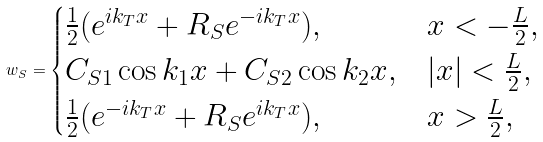<formula> <loc_0><loc_0><loc_500><loc_500>w _ { S } = \begin{cases} \frac { 1 } { 2 } ( e ^ { i k _ { T } x } + R _ { S } e ^ { - i k _ { T } x } ) , & x < - \frac { L } { 2 } , \\ C _ { S 1 } \cos k _ { 1 } x + C _ { S 2 } \cos k _ { 2 } x , & | x | < \frac { L } { 2 } , \\ \frac { 1 } { 2 } ( e ^ { - i k _ { T } x } + R _ { S } e ^ { i k _ { T } x } ) , & x > \frac { L } { 2 } , \end{cases}</formula> 